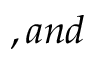Convert formula to latex. <formula><loc_0><loc_0><loc_500><loc_500>, a n d</formula> 